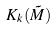Convert formula to latex. <formula><loc_0><loc_0><loc_500><loc_500>K _ { k } ( \tilde { M } )</formula> 